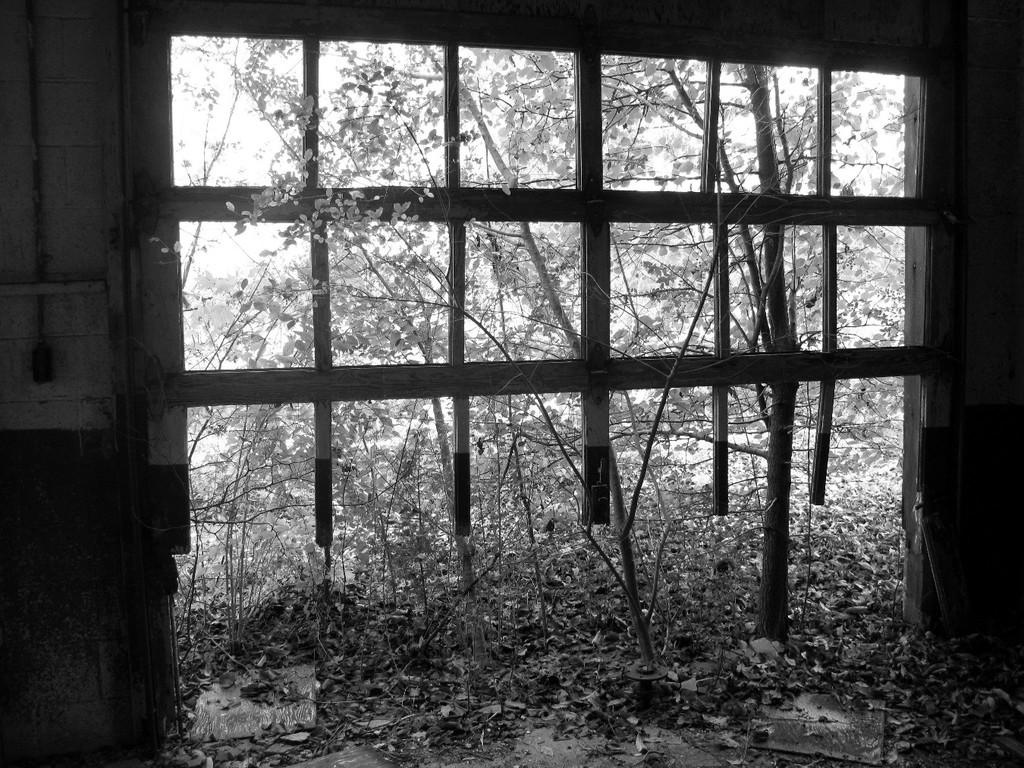What is the main feature of the image? There is a huge window with frames in the image. What can be seen inside the window? There are plants inside the window. What can be seen outside the window? There are plants and trees visible outside the window. What type of lettuce is being used in the war depicted in the image? There is no war or lettuce present in the image; it features a window with plants inside and outside. 